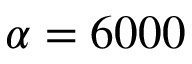Convert formula to latex. <formula><loc_0><loc_0><loc_500><loc_500>\alpha = 6 0 0 0</formula> 